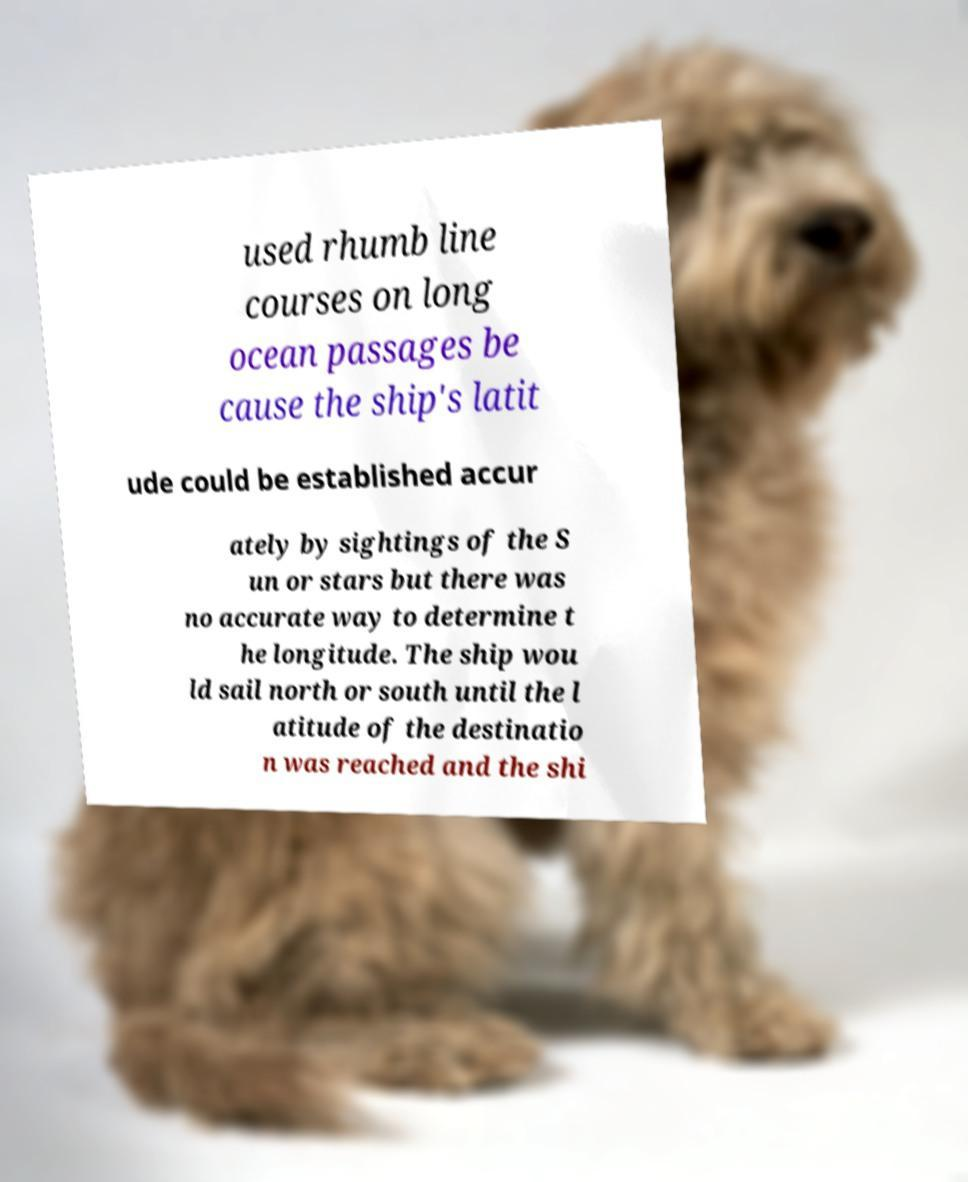For documentation purposes, I need the text within this image transcribed. Could you provide that? used rhumb line courses on long ocean passages be cause the ship's latit ude could be established accur ately by sightings of the S un or stars but there was no accurate way to determine t he longitude. The ship wou ld sail north or south until the l atitude of the destinatio n was reached and the shi 